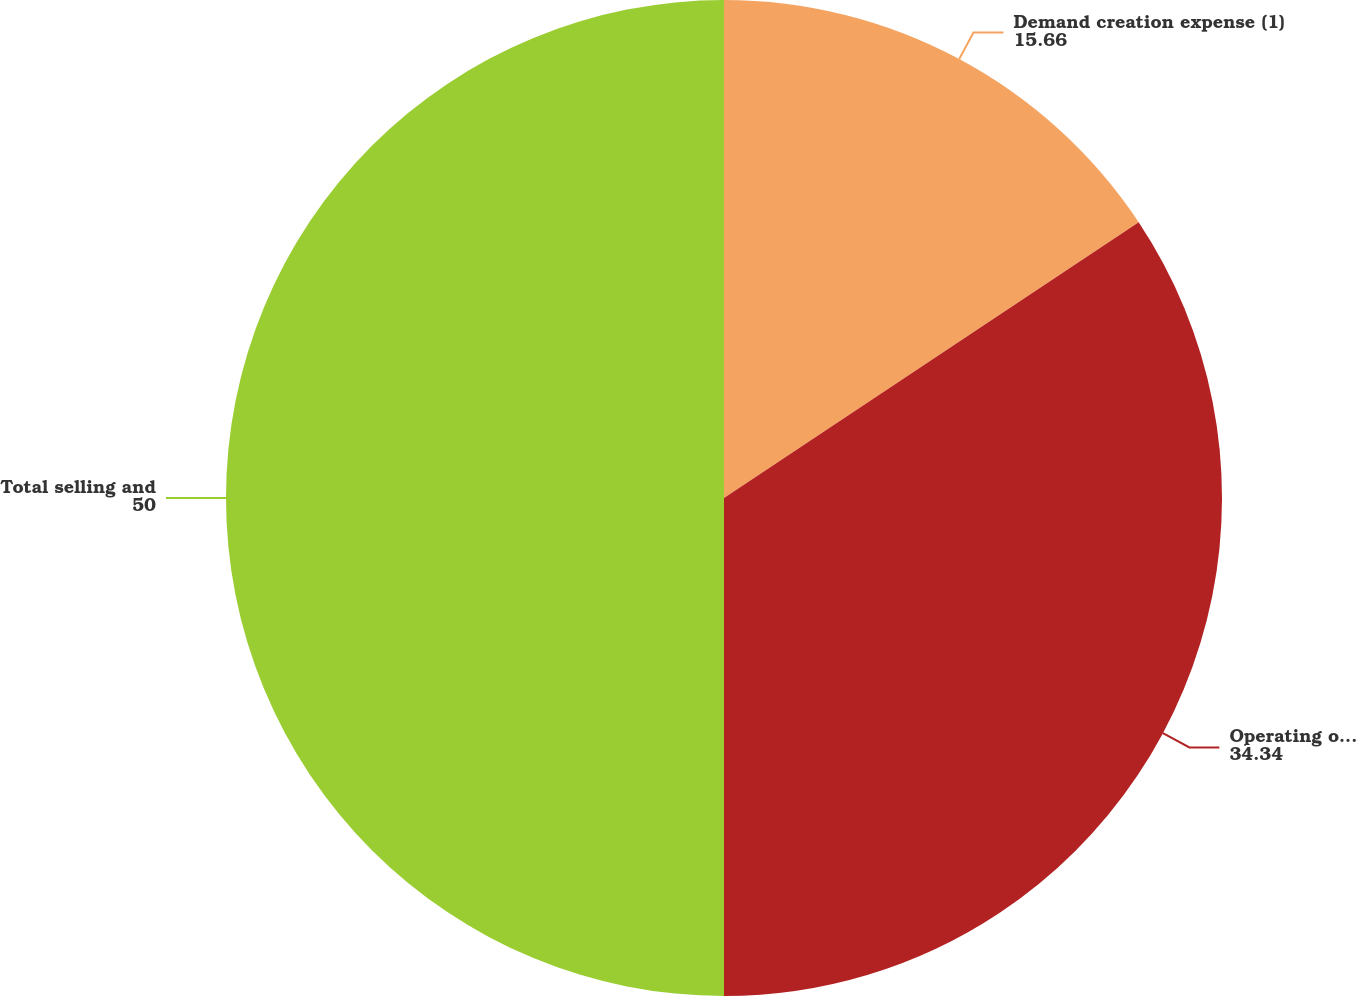<chart> <loc_0><loc_0><loc_500><loc_500><pie_chart><fcel>Demand creation expense (1)<fcel>Operating overhead expense<fcel>Total selling and<nl><fcel>15.66%<fcel>34.34%<fcel>50.0%<nl></chart> 